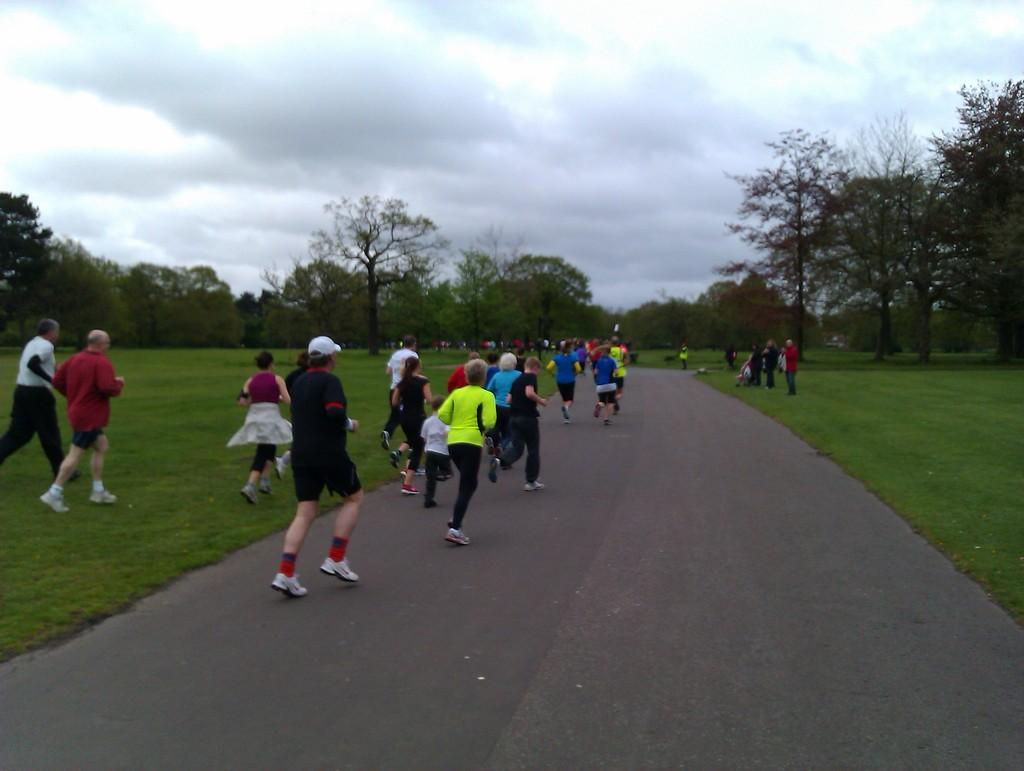What are the people in the image doing? The people in the image are running on the road. What can be seen beside the road in the image? There is grass and trees beside the road in the image. What grade is the tiger in the image? There is no tiger present in the image. How is the aunt related to the people running in the image? There is no mention of an aunt in the image. 